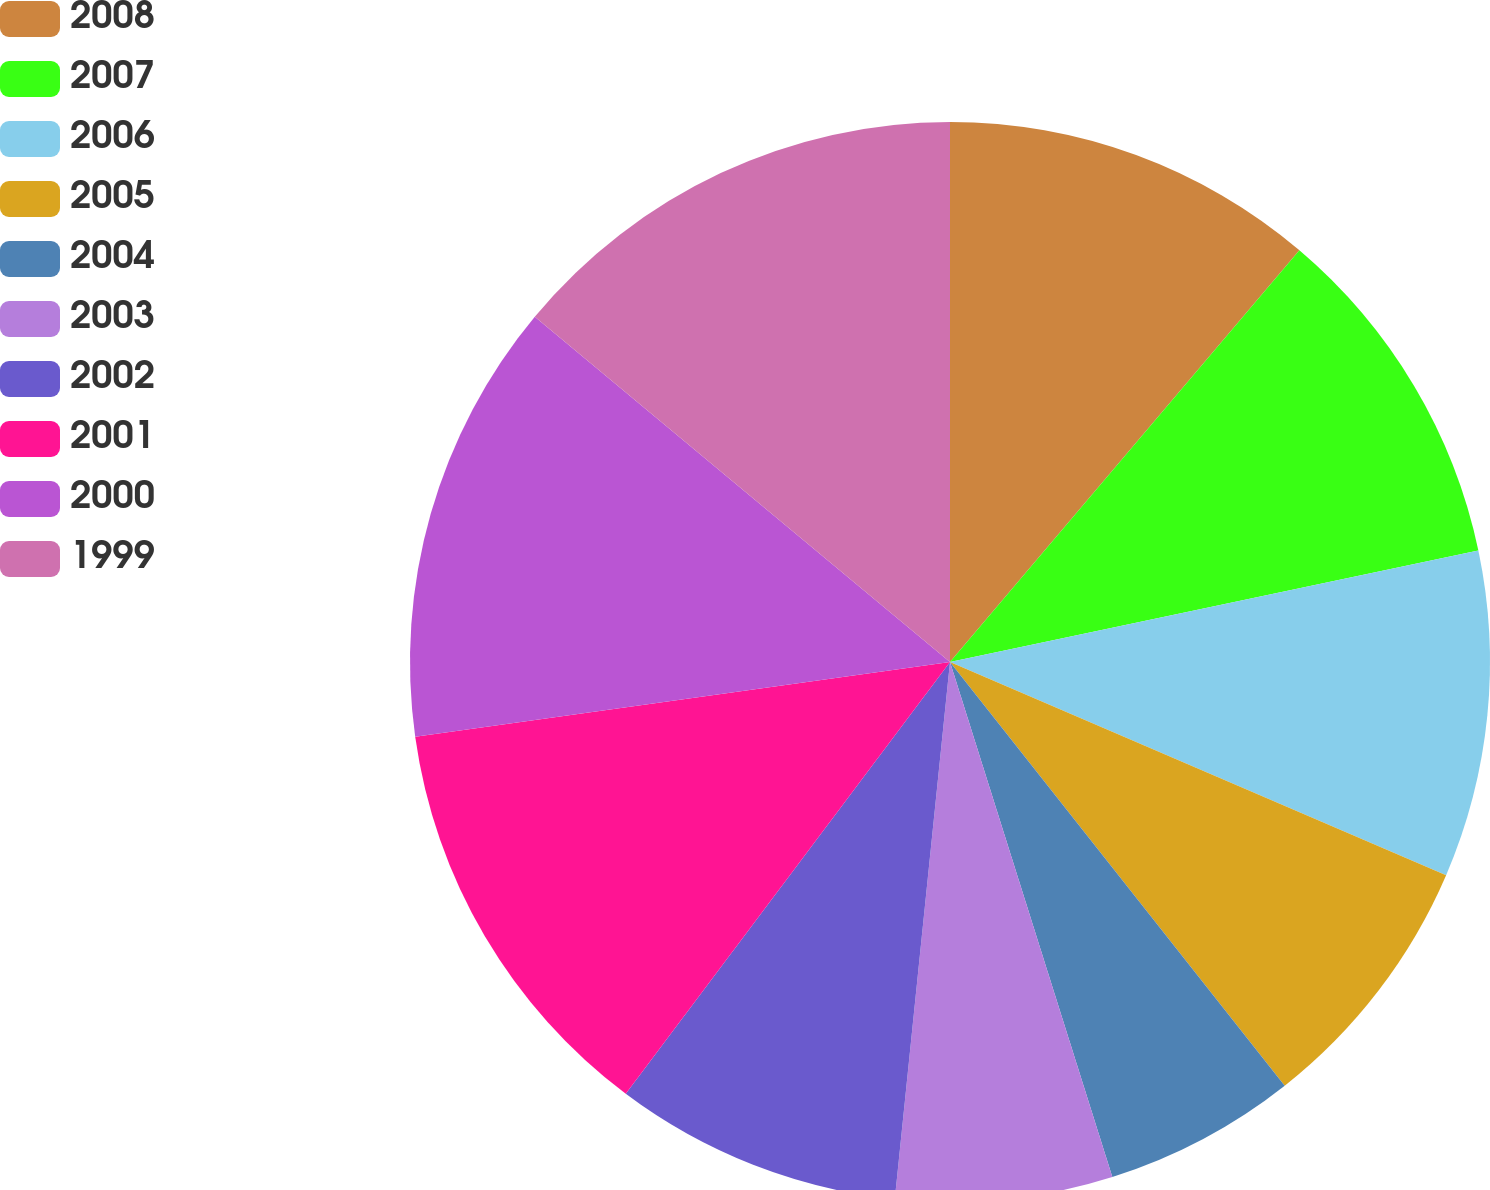<chart> <loc_0><loc_0><loc_500><loc_500><pie_chart><fcel>2008<fcel>2007<fcel>2006<fcel>2005<fcel>2004<fcel>2003<fcel>2002<fcel>2001<fcel>2000<fcel>1999<nl><fcel>11.2%<fcel>10.49%<fcel>9.77%<fcel>7.9%<fcel>5.78%<fcel>6.49%<fcel>8.62%<fcel>12.54%<fcel>13.25%<fcel>13.96%<nl></chart> 